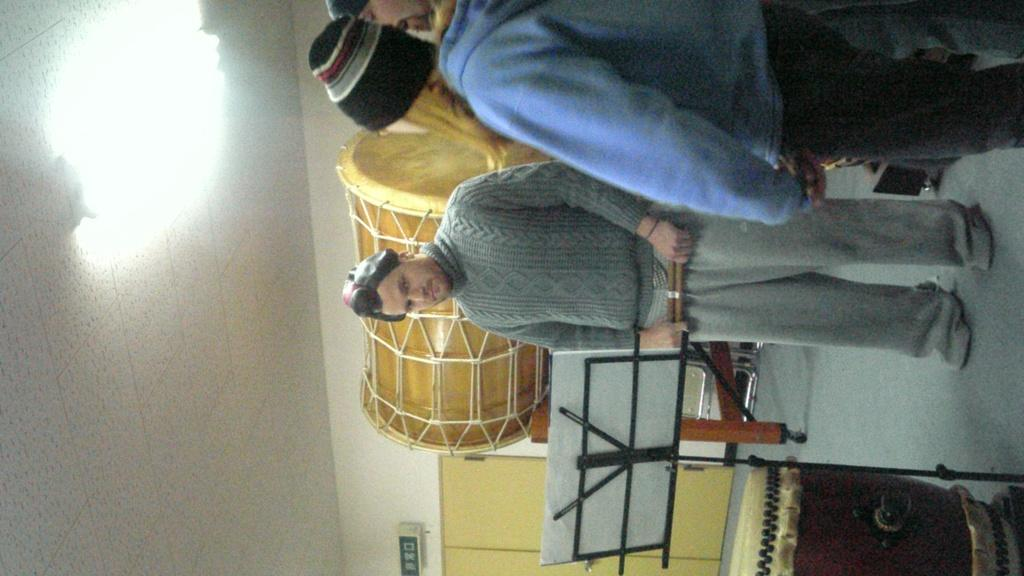What can be seen in the image? There are men standing in the image. What are the men wearing on their heads? The men are wearing caps. Can you describe anything in the background of the image? There is a musical instrument in the background of the image. How many bikes are being kicked in the image? There are no bikes present in the image. 